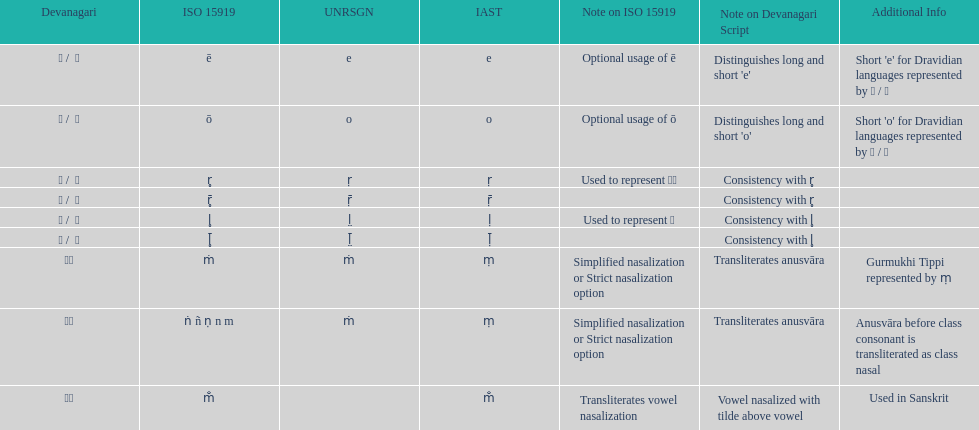What is the total number of translations? 8. 